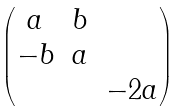Convert formula to latex. <formula><loc_0><loc_0><loc_500><loc_500>\begin{pmatrix} a & b & \\ - b & a & \\ & & - 2 a \end{pmatrix}</formula> 